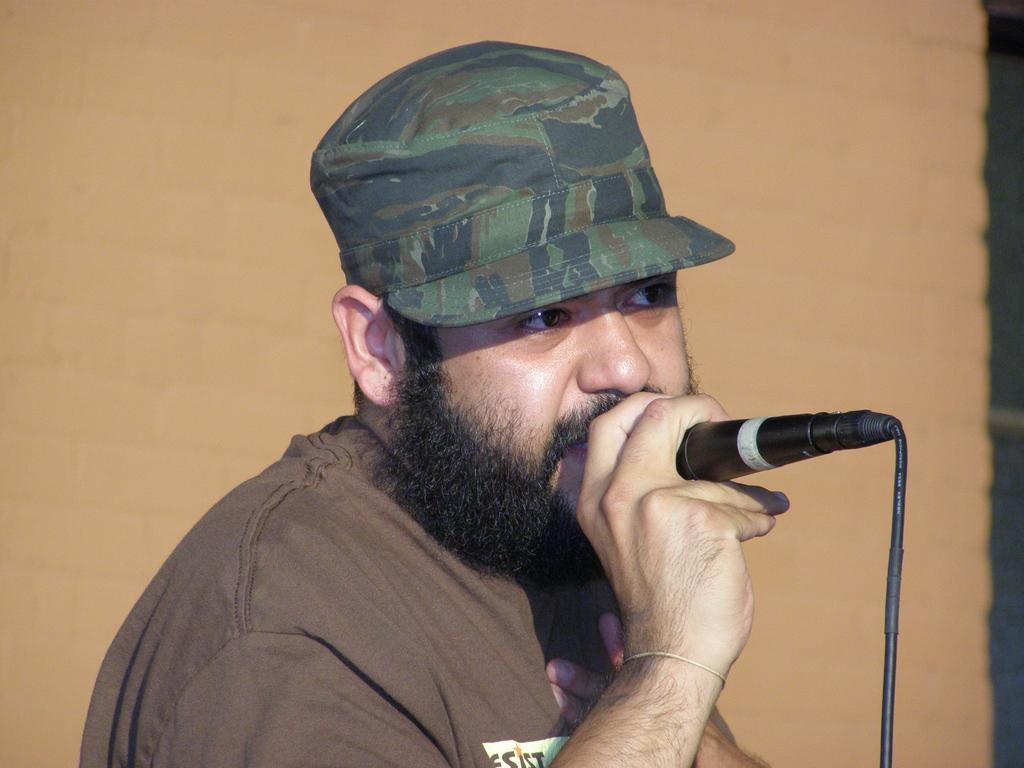What is the main subject of the image? The main subject of the image is a man. What is the man wearing on his upper body? The man is wearing a brown t-shirt. What is the man wearing on his head? The man is wearing a cap on his head. What is the man holding in his hand? The man is holding a mic. What type of horn can be seen on the man's head in the image? There is no horn present on the man's head in the image; he is wearing a cap. 